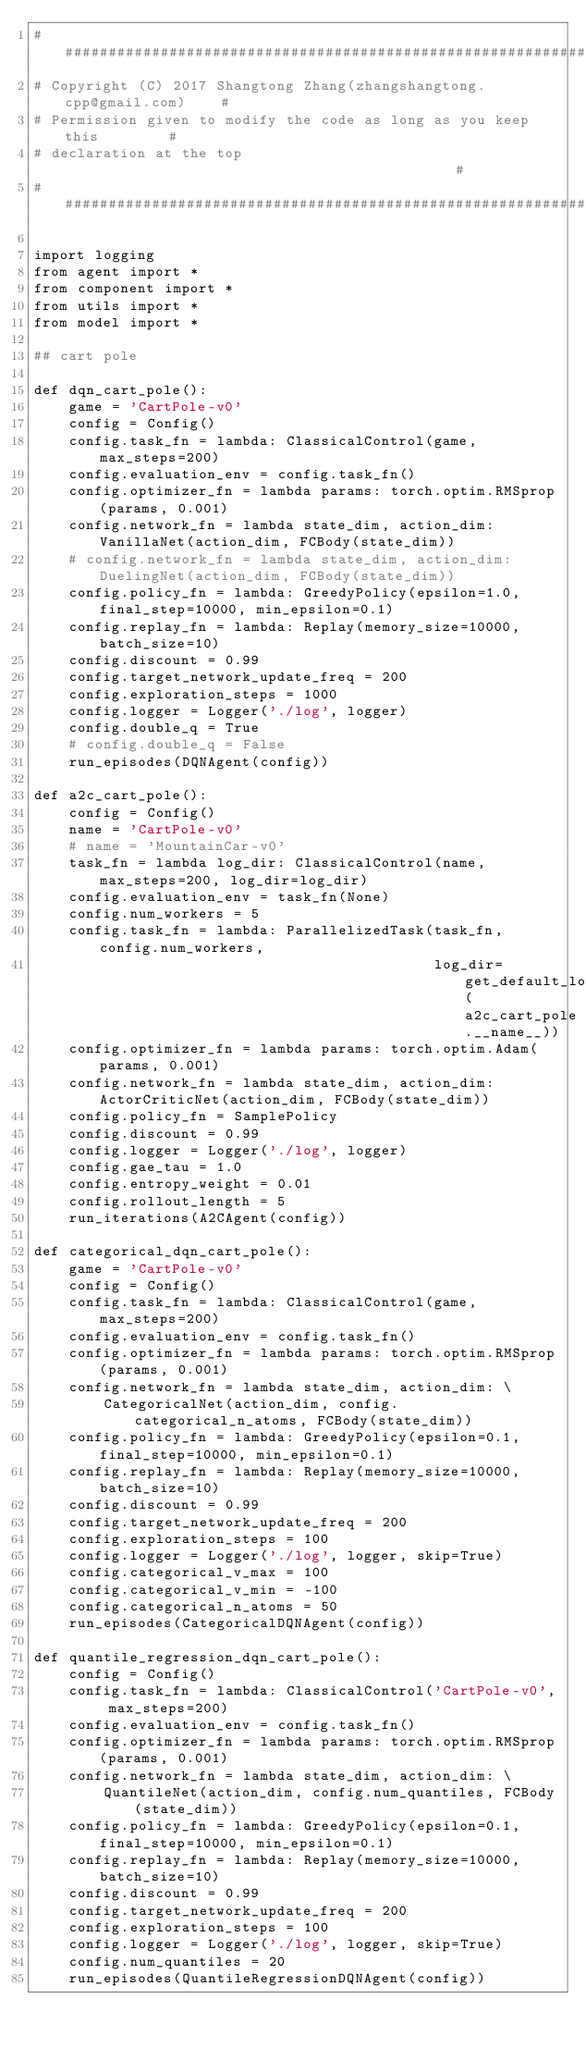<code> <loc_0><loc_0><loc_500><loc_500><_Python_>#######################################################################
# Copyright (C) 2017 Shangtong Zhang(zhangshangtong.cpp@gmail.com)    #
# Permission given to modify the code as long as you keep this        #
# declaration at the top                                              #
#######################################################################

import logging
from agent import *
from component import *
from utils import *
from model import *

## cart pole

def dqn_cart_pole():
    game = 'CartPole-v0'
    config = Config()
    config.task_fn = lambda: ClassicalControl(game, max_steps=200)
    config.evaluation_env = config.task_fn()
    config.optimizer_fn = lambda params: torch.optim.RMSprop(params, 0.001)
    config.network_fn = lambda state_dim, action_dim: VanillaNet(action_dim, FCBody(state_dim))
    # config.network_fn = lambda state_dim, action_dim: DuelingNet(action_dim, FCBody(state_dim))
    config.policy_fn = lambda: GreedyPolicy(epsilon=1.0, final_step=10000, min_epsilon=0.1)
    config.replay_fn = lambda: Replay(memory_size=10000, batch_size=10)
    config.discount = 0.99
    config.target_network_update_freq = 200
    config.exploration_steps = 1000
    config.logger = Logger('./log', logger)
    config.double_q = True
    # config.double_q = False
    run_episodes(DQNAgent(config))

def a2c_cart_pole():
    config = Config()
    name = 'CartPole-v0'
    # name = 'MountainCar-v0'
    task_fn = lambda log_dir: ClassicalControl(name, max_steps=200, log_dir=log_dir)
    config.evaluation_env = task_fn(None)
    config.num_workers = 5
    config.task_fn = lambda: ParallelizedTask(task_fn, config.num_workers,
                                              log_dir=get_default_log_dir(a2c_cart_pole.__name__))
    config.optimizer_fn = lambda params: torch.optim.Adam(params, 0.001)
    config.network_fn = lambda state_dim, action_dim: ActorCriticNet(action_dim, FCBody(state_dim))
    config.policy_fn = SamplePolicy
    config.discount = 0.99
    config.logger = Logger('./log', logger)
    config.gae_tau = 1.0
    config.entropy_weight = 0.01
    config.rollout_length = 5
    run_iterations(A2CAgent(config))

def categorical_dqn_cart_pole():
    game = 'CartPole-v0'
    config = Config()
    config.task_fn = lambda: ClassicalControl(game, max_steps=200)
    config.evaluation_env = config.task_fn()
    config.optimizer_fn = lambda params: torch.optim.RMSprop(params, 0.001)
    config.network_fn = lambda state_dim, action_dim: \
        CategoricalNet(action_dim, config.categorical_n_atoms, FCBody(state_dim))
    config.policy_fn = lambda: GreedyPolicy(epsilon=0.1, final_step=10000, min_epsilon=0.1)
    config.replay_fn = lambda: Replay(memory_size=10000, batch_size=10)
    config.discount = 0.99
    config.target_network_update_freq = 200
    config.exploration_steps = 100
    config.logger = Logger('./log', logger, skip=True)
    config.categorical_v_max = 100
    config.categorical_v_min = -100
    config.categorical_n_atoms = 50
    run_episodes(CategoricalDQNAgent(config))

def quantile_regression_dqn_cart_pole():
    config = Config()
    config.task_fn = lambda: ClassicalControl('CartPole-v0', max_steps=200)
    config.evaluation_env = config.task_fn()
    config.optimizer_fn = lambda params: torch.optim.RMSprop(params, 0.001)
    config.network_fn = lambda state_dim, action_dim: \
        QuantileNet(action_dim, config.num_quantiles, FCBody(state_dim))
    config.policy_fn = lambda: GreedyPolicy(epsilon=0.1, final_step=10000, min_epsilon=0.1)
    config.replay_fn = lambda: Replay(memory_size=10000, batch_size=10)
    config.discount = 0.99
    config.target_network_update_freq = 200
    config.exploration_steps = 100
    config.logger = Logger('./log', logger, skip=True)
    config.num_quantiles = 20
    run_episodes(QuantileRegressionDQNAgent(config))
</code> 